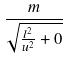<formula> <loc_0><loc_0><loc_500><loc_500>\frac { m } { \sqrt { \frac { l ^ { 2 } } { u ^ { 2 } } + 0 } }</formula> 